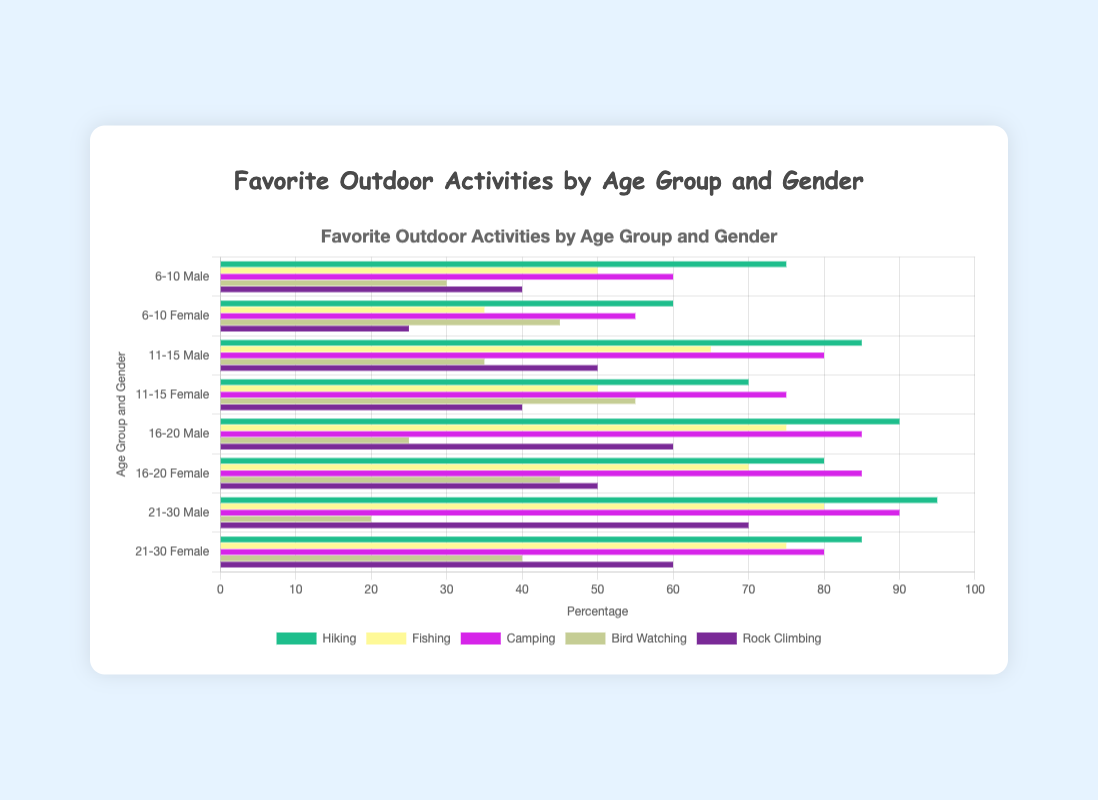Which age group has the highest preference for Rock Climbing? Looking at the bars related to Rock Climbing, the 21-30 Male group shows the highest preference with a value of 70.
Answer: 21-30 Male Compare the preference for Hiking between 6-10 Female and 16-20 Female age groups. The 6-10 Female group has a preference of 60 for Hiking, while the 16-20 Female group has a preference of 80. The 16-20 Female group prefers Hiking more than the 6-10 Female group.
Answer: 16-20 Female Which gender has a higher preference for Camping in the 11-15 age group, and by how much? In the 11-15 age group, males have a preference of 80 for Camping, and females have a preference of 75. Males prefer Camping 5 more than females in this age group.
Answer: Male, by 5 What is the percentage difference in the preference for Bird Watching between the 11-15 Female and 21-30 Male groups? The 11-15 Female group has a preference of 55, and the 21-30 Male group has a preference of 20. The difference is 55 - 20 = 35, which can be found as (35/55) * 100 = 63.64%.
Answer: 63.64% What is the total preference for Hiking among the Male groups across all age ranges? Sum preferences for Hiking in all Male age groups: 75 (6-10) + 85 (11-15) + 90 (16-20) + 95 (21-30) = 345.
Answer: 345 How does the preference for Fishing compare between the genders in the 6-10 age group? In the 6-10 age group, Males have a preference of 50, and Females have a preference of 35 for Fishing. Males prefer Fishing more than Females by 15.
Answer: Males, by 15 What is the average preference for Bird Watching across all age groups for the Female gender? Adding the Bird Watching preferences for females: 45 (6-10) + 55 (11-15) + 45 (16-20) + 40 (21-30) = 185. There are 4 age groups, so the average is 185 / 4 = 46.25.
Answer: 46.25 Which outdoor activity shows the least preference among the 21-30 Female group, and what percentage is it? For the 21-30 Female group, Bird Watching is the least preferred activity with a value of 40.
Answer: Bird Watching, 40 